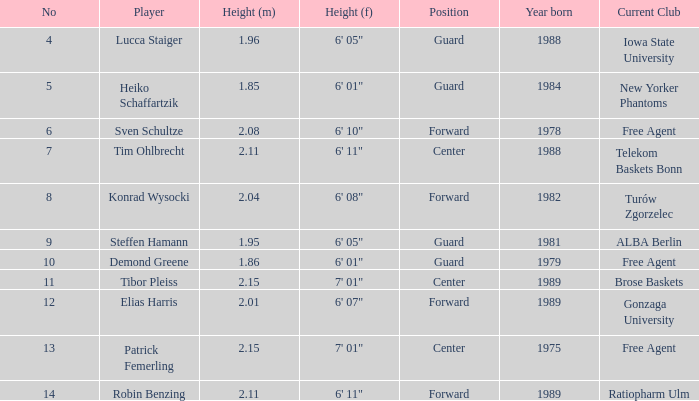Name the height of demond greene 6' 01". 